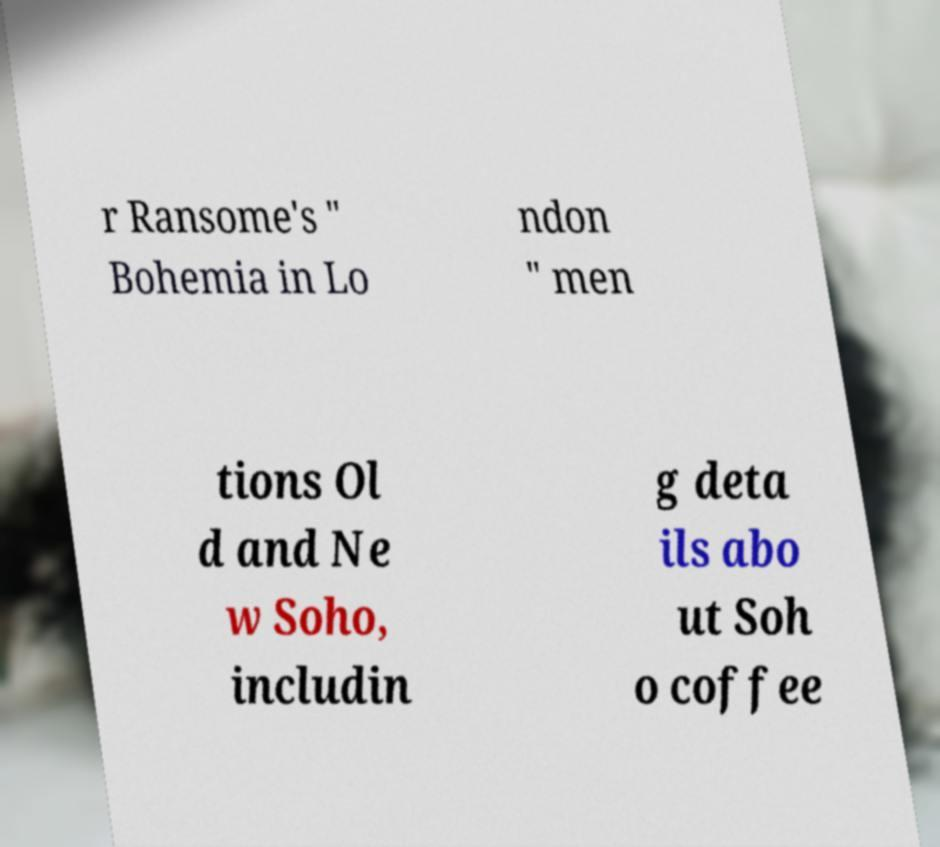I need the written content from this picture converted into text. Can you do that? r Ransome's " Bohemia in Lo ndon " men tions Ol d and Ne w Soho, includin g deta ils abo ut Soh o coffee 